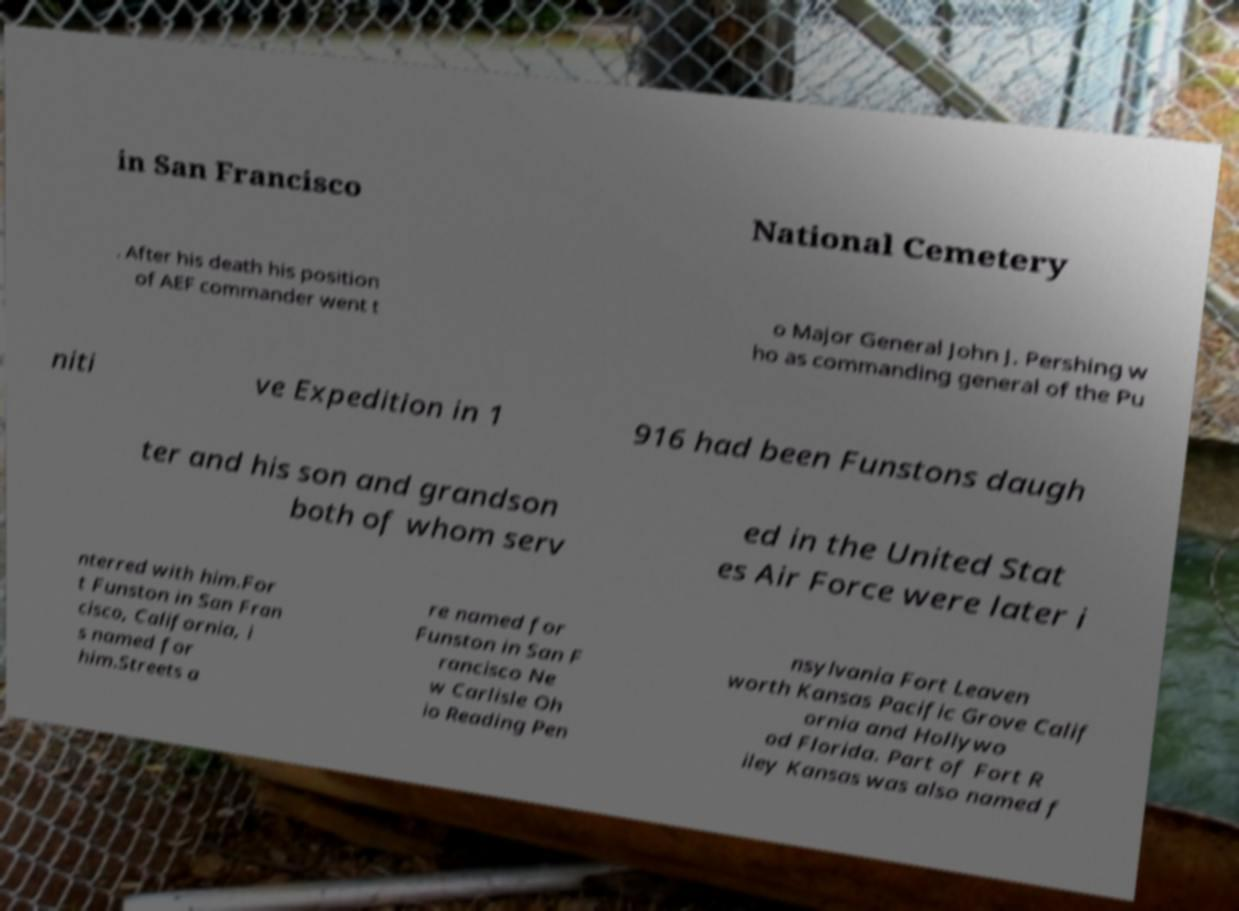Could you extract and type out the text from this image? in San Francisco National Cemetery . After his death his position of AEF commander went t o Major General John J. Pershing w ho as commanding general of the Pu niti ve Expedition in 1 916 had been Funstons daugh ter and his son and grandson both of whom serv ed in the United Stat es Air Force were later i nterred with him.For t Funston in San Fran cisco, California, i s named for him.Streets a re named for Funston in San F rancisco Ne w Carlisle Oh io Reading Pen nsylvania Fort Leaven worth Kansas Pacific Grove Calif ornia and Hollywo od Florida. Part of Fort R iley Kansas was also named f 